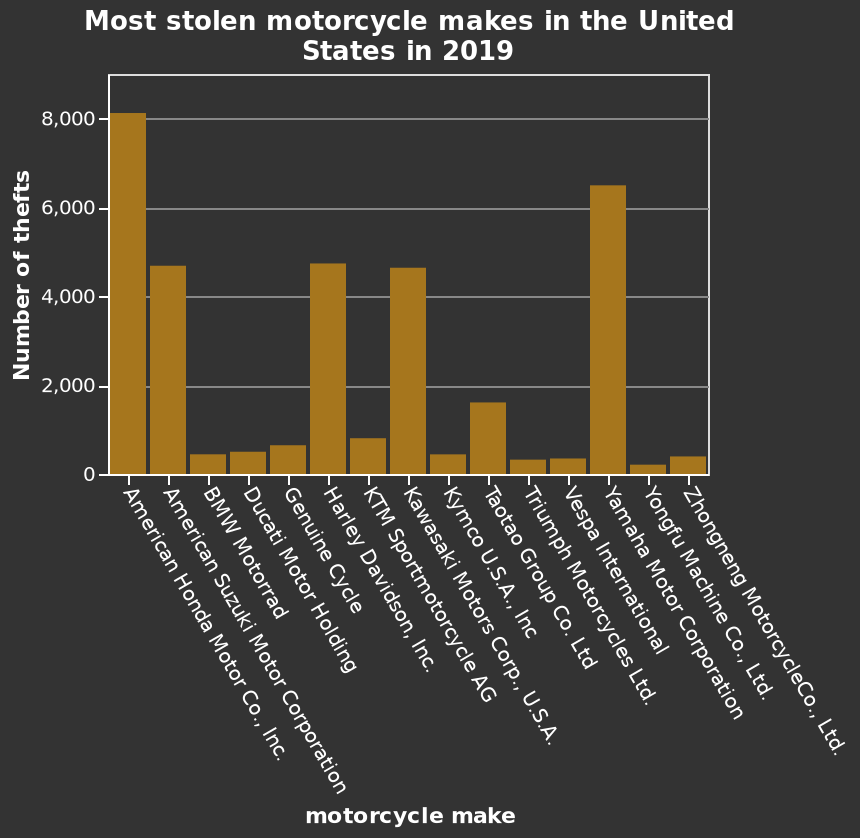<image>
Does the figure provide information about the total number of available motorbikes to steal?  No, the figure does not provide the context of how many motorbikes are available to steal. Which brands are less likely to be stolen?  The other brands, excluding Honda, hahaha, Suzuki, Harley, and Kawasaki, are less likely to be stolen. please enumerates aspects of the construction of the chart This is a bar graph labeled Most stolen motorcycle makes in the United States in 2019. The y-axis measures Number of thefts along linear scale of range 0 to 8,000 while the x-axis plots motorcycle make using categorical scale with American Honda Motor Co., Inc. on one end and Zhongneng MotorcycleCo., Ltd. at the other. What is the range of the y-axis in the bar graph? The range of the y-axis in the bar graph is from 0 to 8,000. 